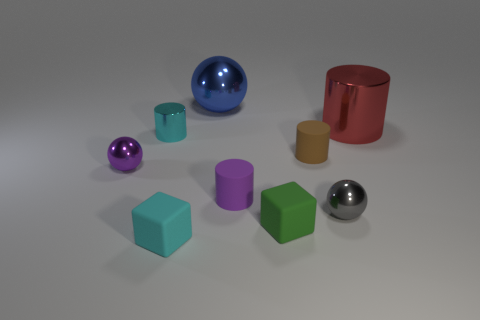Subtract all red cylinders. How many cylinders are left? 3 Subtract all cubes. How many objects are left? 7 Add 9 small red cubes. How many small red cubes exist? 9 Subtract 1 blue balls. How many objects are left? 8 Subtract all rubber spheres. Subtract all small blocks. How many objects are left? 7 Add 6 gray shiny things. How many gray shiny things are left? 7 